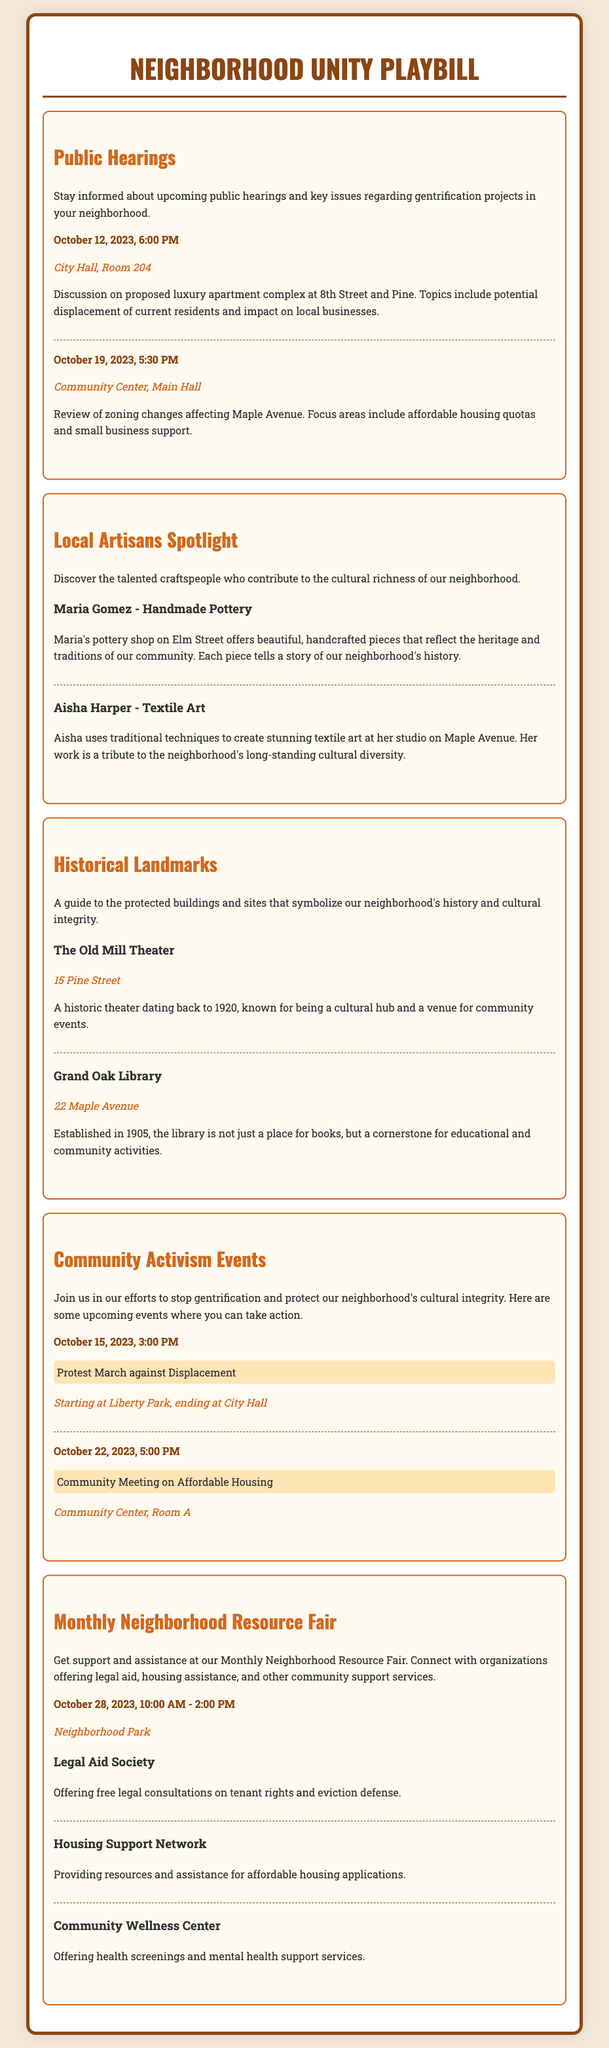What date is the public hearing on the luxury apartment complex? The date of the public hearing is specified in the document as October 12, 2023.
Answer: October 12, 2023 Where will the community meeting on affordable housing take place? The location of the community meeting is mentioned in the document as Community Center, Room A.
Answer: Community Center, Room A What time does the Monthly Neighborhood Resource Fair start? The opening time for the resource fair is indicated in the document as 10:00 AM.
Answer: 10:00 AM Who is highlighted as a local artisan known for textile art? The document names Aisha Harper as the local artisan specializing in textile art.
Answer: Aisha Harper What is the main topic of discussion at the October 19 public hearing? The topic for the hearing includes zoning changes affecting Maple Avenue, focusing on affordable housing quotas and small business support.
Answer: Zoning changes How many community activism events are listed in the document? The document lists two community activism events, specifically the protest march and the community meeting.
Answer: Two What type of support does the Legal Aid Society offer? The document describes the Legal Aid Society as offering free legal consultations on tenant rights and eviction defense.
Answer: Tenant rights consultations What is the location of The Old Mill Theater? The Old Mill Theater's address is provided in the document as 15 Pine Street.
Answer: 15 Pine Street When is the protest march against displacement scheduled? The document specifies that the protest march is scheduled for October 15, 2023, at 3:00 PM.
Answer: October 15, 2023, 3:00 PM 